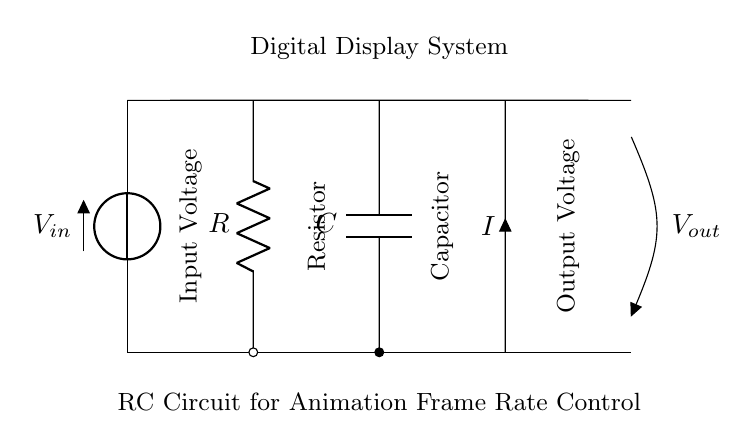What is the name of the first component in the circuit? The first component in the circuit, positioned at the top left, is labeled as a voltage source (V).
Answer: Voltage Source What is the label on the resistor? The resistor is labeled with the letter R in the circuit diagram, indicating its component type.
Answer: R What type of component is situated between the resistor and the output? The component between the resistor and the output is labeled as a capacitor (C), which is used in RC circuits.
Answer: Capacitor What does the circuit control in digital display systems? The circuit is designed to control the animation frame rate in digital display systems by adjusting the time constant.
Answer: Animation frame rate How does increasing the resistance affect the time constant of the circuit? Increasing the resistance will result in a larger time constant (τ), which slows down the charging and discharging time of the capacitor, resulting in a lower frame rate for animations.
Answer: Slows down What is the relationship between voltage output and input in this RC circuit? The output voltage is a function of the input voltage and is influenced by the resistor and capacitor values, resulting in a charge that follows an exponential curve based on the time constant (τ = RC).
Answer: Exponential curve 